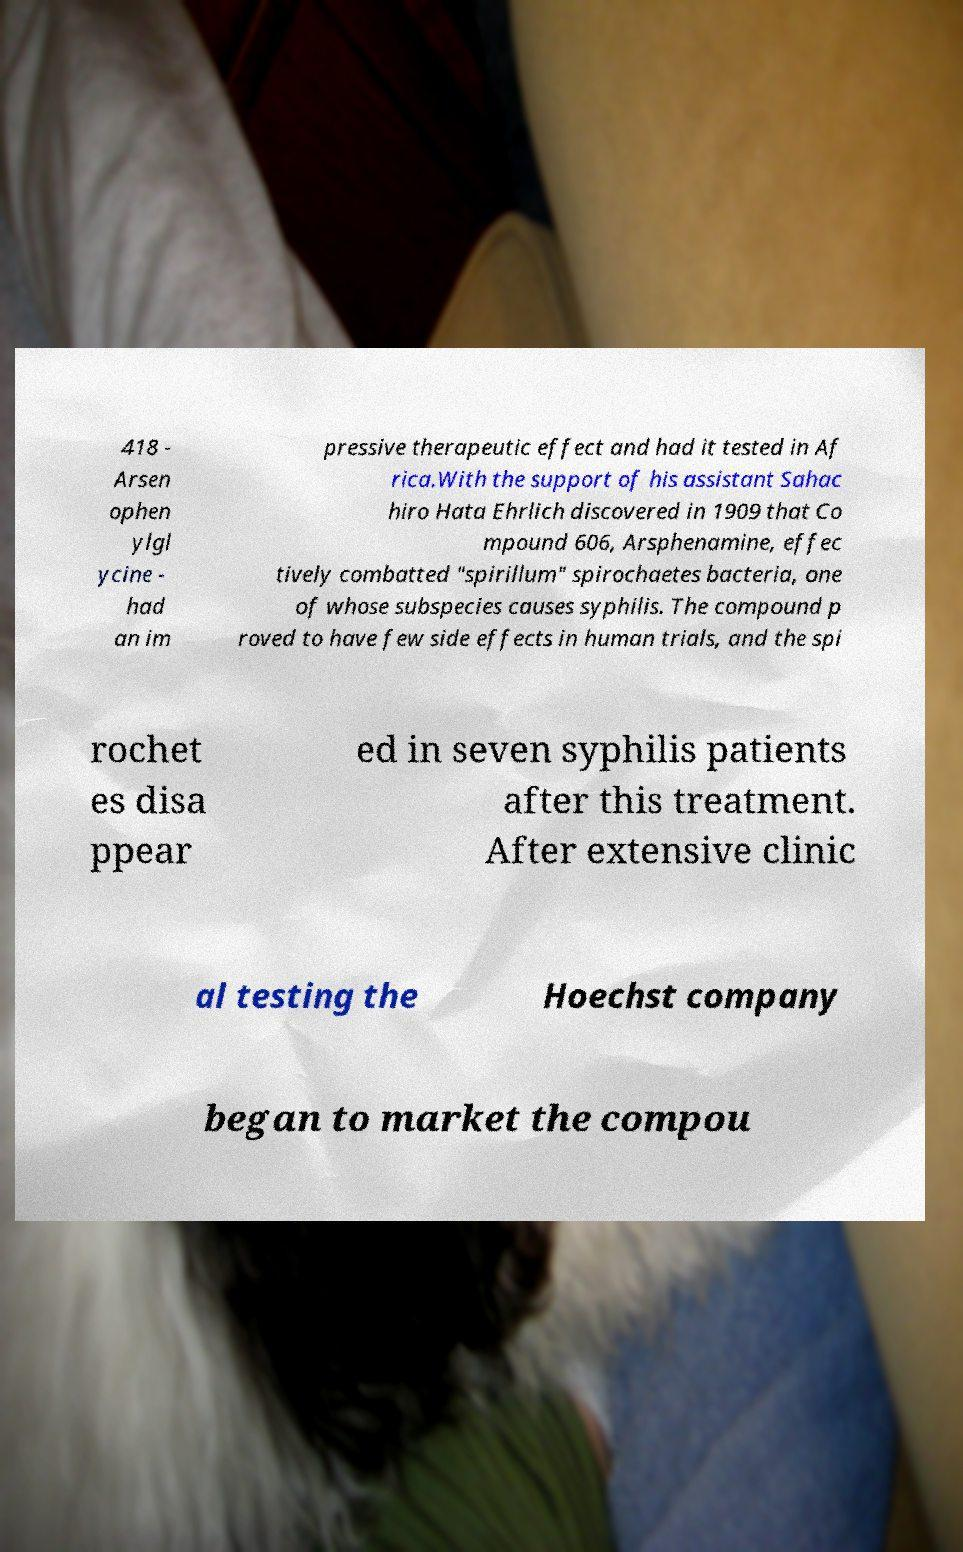Could you assist in decoding the text presented in this image and type it out clearly? 418 - Arsen ophen ylgl ycine - had an im pressive therapeutic effect and had it tested in Af rica.With the support of his assistant Sahac hiro Hata Ehrlich discovered in 1909 that Co mpound 606, Arsphenamine, effec tively combatted "spirillum" spirochaetes bacteria, one of whose subspecies causes syphilis. The compound p roved to have few side effects in human trials, and the spi rochet es disa ppear ed in seven syphilis patients after this treatment. After extensive clinic al testing the Hoechst company began to market the compou 